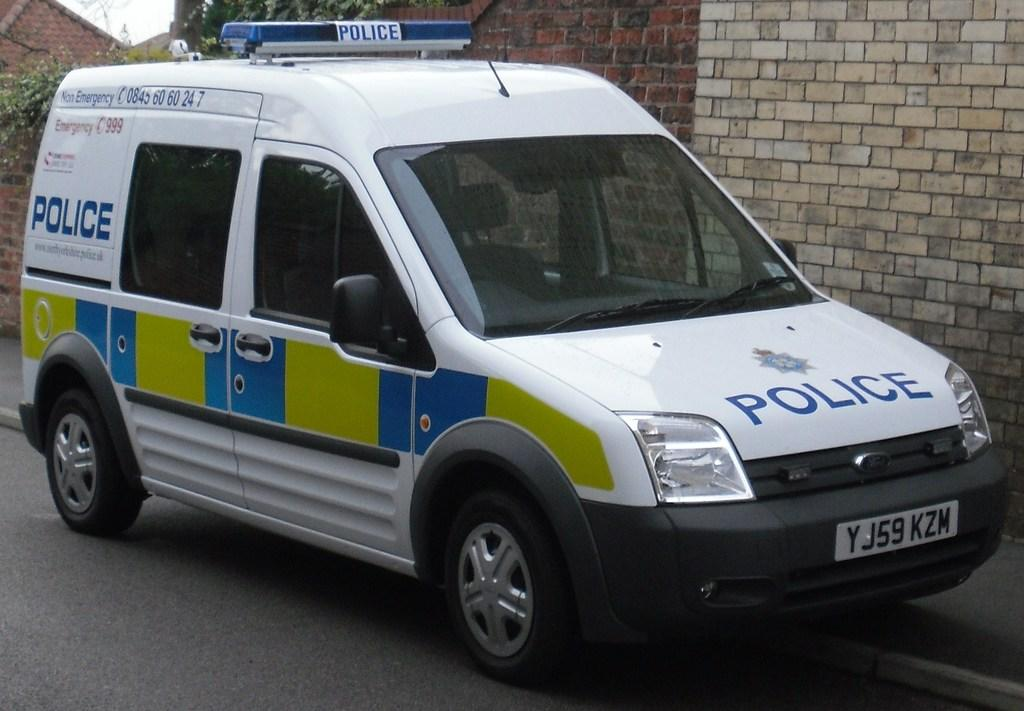<image>
Provide a brief description of the given image. A police van is parked on a street. 